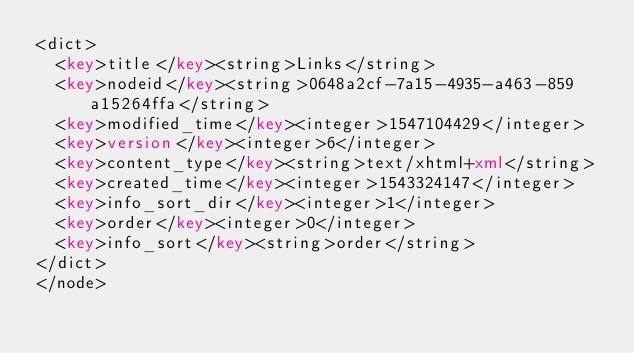Convert code to text. <code><loc_0><loc_0><loc_500><loc_500><_XML_><dict>
  <key>title</key><string>Links</string>
  <key>nodeid</key><string>0648a2cf-7a15-4935-a463-859a15264ffa</string>
  <key>modified_time</key><integer>1547104429</integer>
  <key>version</key><integer>6</integer>
  <key>content_type</key><string>text/xhtml+xml</string>
  <key>created_time</key><integer>1543324147</integer>
  <key>info_sort_dir</key><integer>1</integer>
  <key>order</key><integer>0</integer>
  <key>info_sort</key><string>order</string>
</dict>
</node>
</code> 